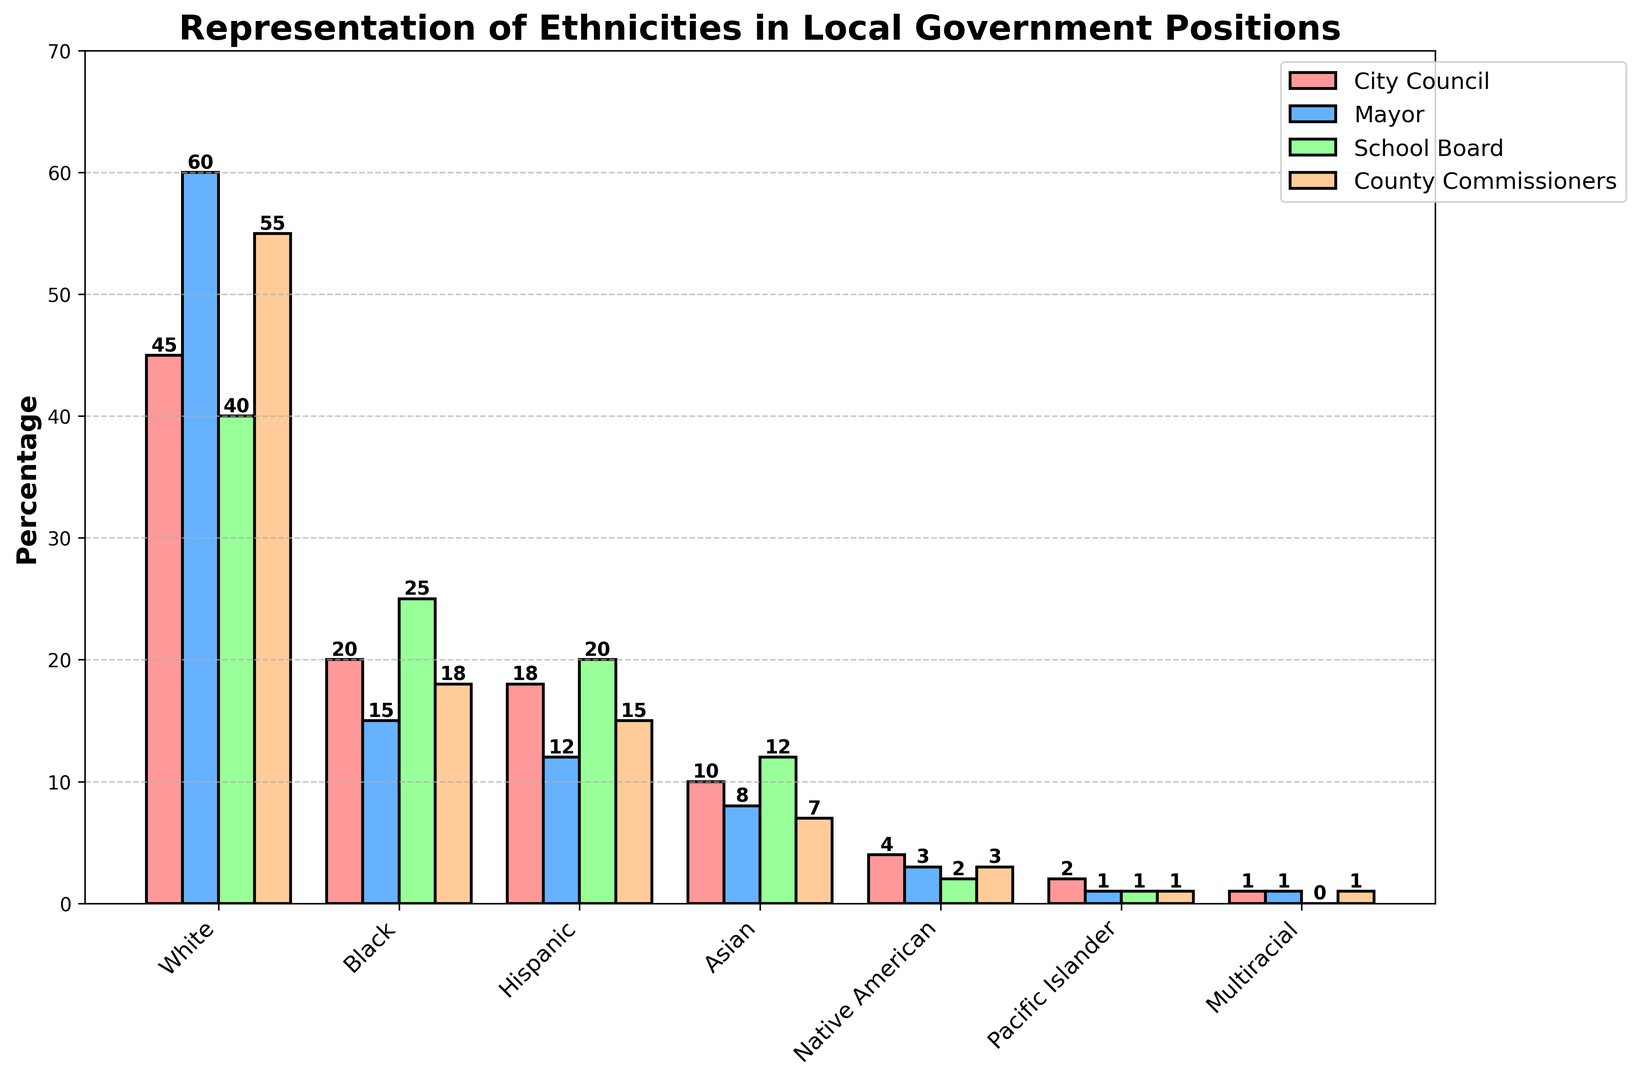Which ethnic group has the highest representation in the Mayor position? Observe the bars representing the Mayor position for each ethnic group. The tallest bar correlates with the "White" category at 60%.
Answer: White What is the total representation percentage of Black individuals across all positions? Sum the percentages of Black individuals across all positions (City Council: 20, Mayor: 15, School Board: 25, County Commissioners: 18). Total = 20 + 15 + 25 + 18 = 78.
Answer: 78 Which ethnic group has a higher representation in the School Board position: Asian or Hispanic? Compare the heights of the bars representing the School Board position for Asian (12%) and Hispanic (20%) groups.
Answer: Hispanic What is the difference in the percentage representation between White and Native American individuals in City Council positions? Subtract the percentage representation of the Native American group (4%) from the White group (45%) in the City Council position. Difference = 45 - 4 = 41.
Answer: 41 Which ethnic category has consistently lower representation across all positions? Observe the bars for all positions and identify which category consistently has the smallest bars. The "Pacific Islander" category has the lowest representation (1-2%).
Answer: Pacific Islander In which position is the representation of Hispanic individuals closest to that of Asian individuals? Compare the bars for Hispanic and Asian individuals across all positions. The School Board position has Hispanic at 20% and Asian at 12%, the closest comparison.
Answer: School Board What is the combined representation percentage of the Pacific Islander group in the City Council and County Commissioners positions? Sum the percentages of the Pacific Islander group in City Council (2%) and County Commissioners (1%) positions. Total = 2 + 1 = 3.
Answer: 3 How does the representation of Multiracial individuals in the School Board compare to their representation in the Mayor position? Compare the Multiracial group's representation bars in the School Board (0%) and Mayor (1%) positions.
Answer: Higher in Mayor What is the average representation percentage of White individuals across all positions? Sum the percentages of White individuals across all positions (City Council: 45, Mayor: 60, School Board: 40, County Commissioners: 55). Total = 45 + 60 + 40 + 55 = 200. Average = 200 / 4 = 50.
Answer: 50 Which position has the highest variation in representation percentages across different ethnic groups? Compare the range of representation percentages across all positions. The Mayor position varies from 1% (Pacific Islander) to 60% (White).
Answer: Mayor 